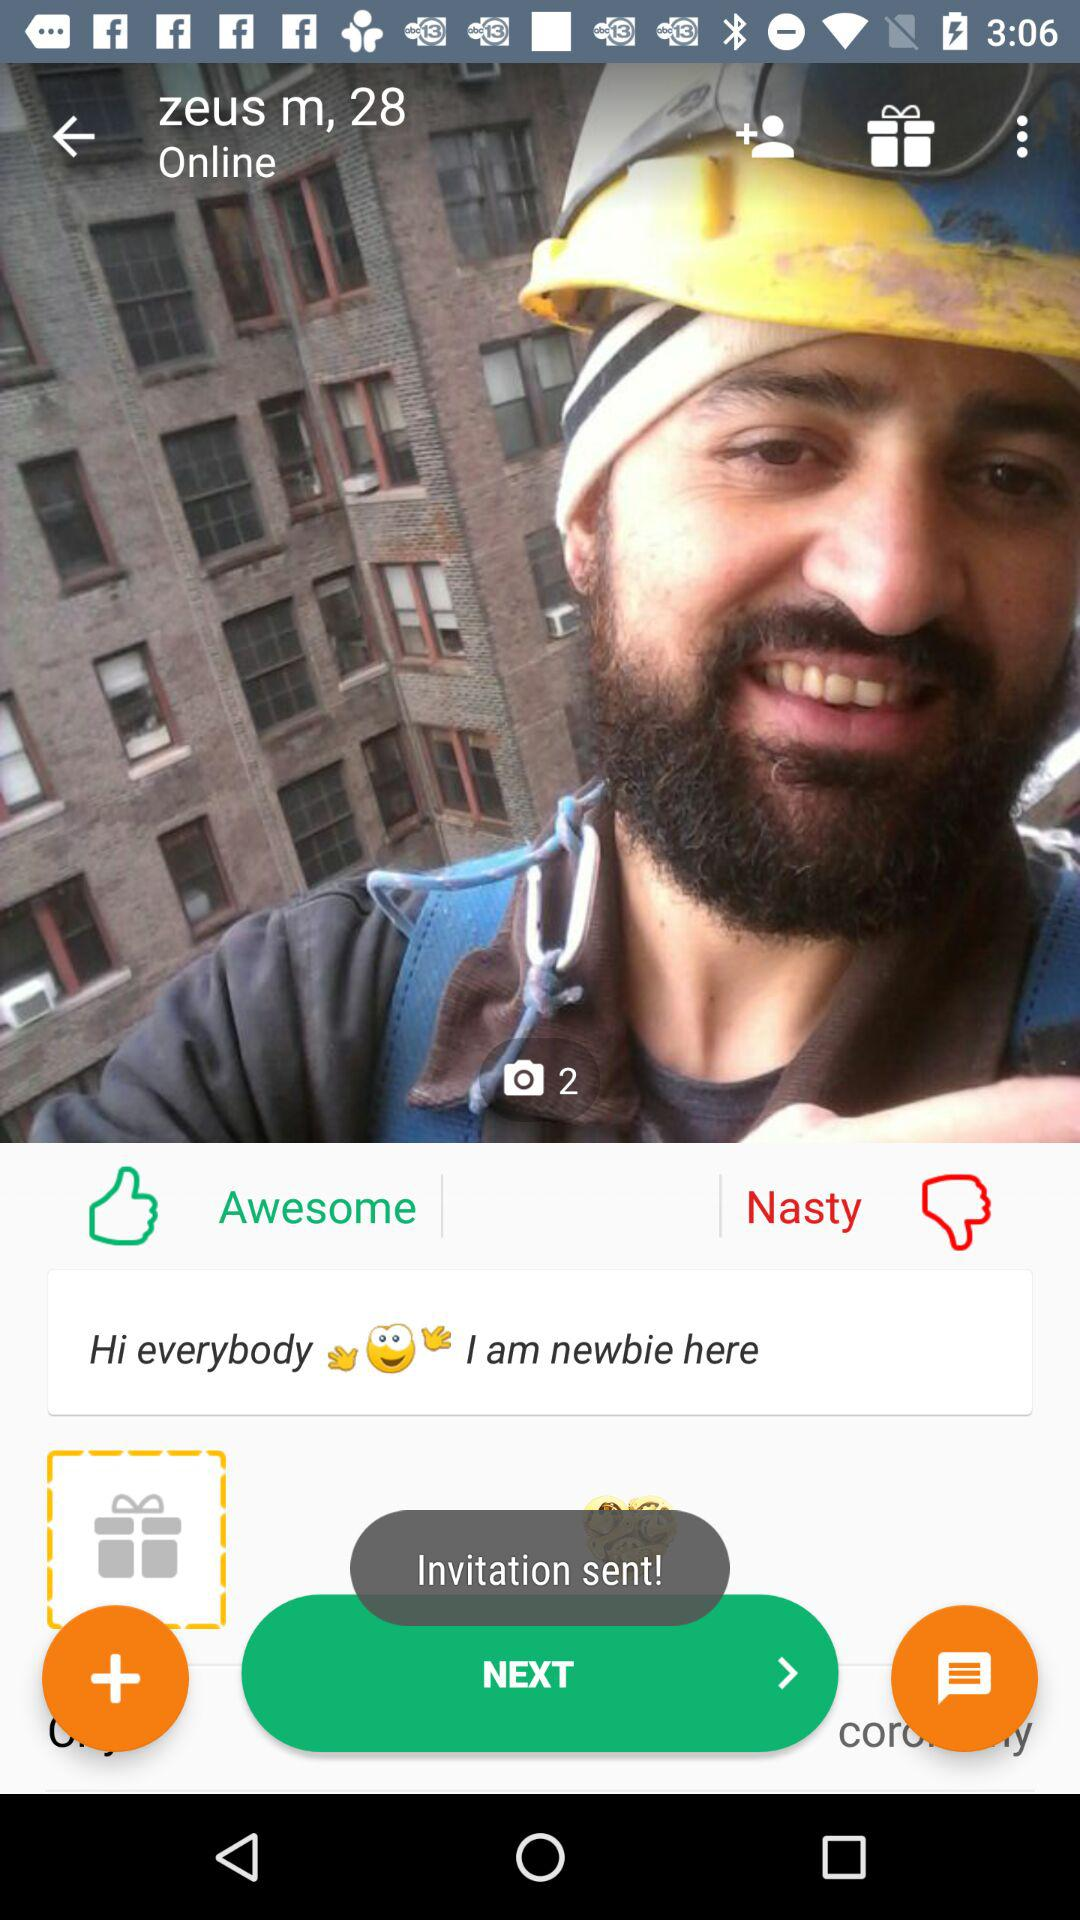Where does "zeus" live?
When the provided information is insufficient, respond with <no answer>. <no answer> 